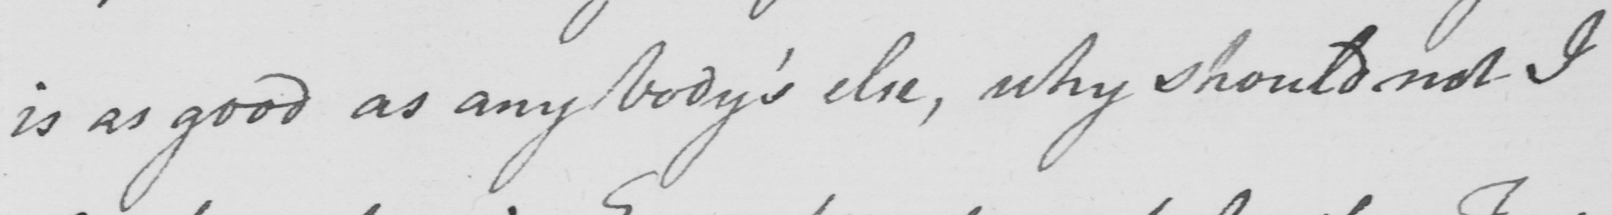Please transcribe the handwritten text in this image. is as good as any body ' s else , why should not I 